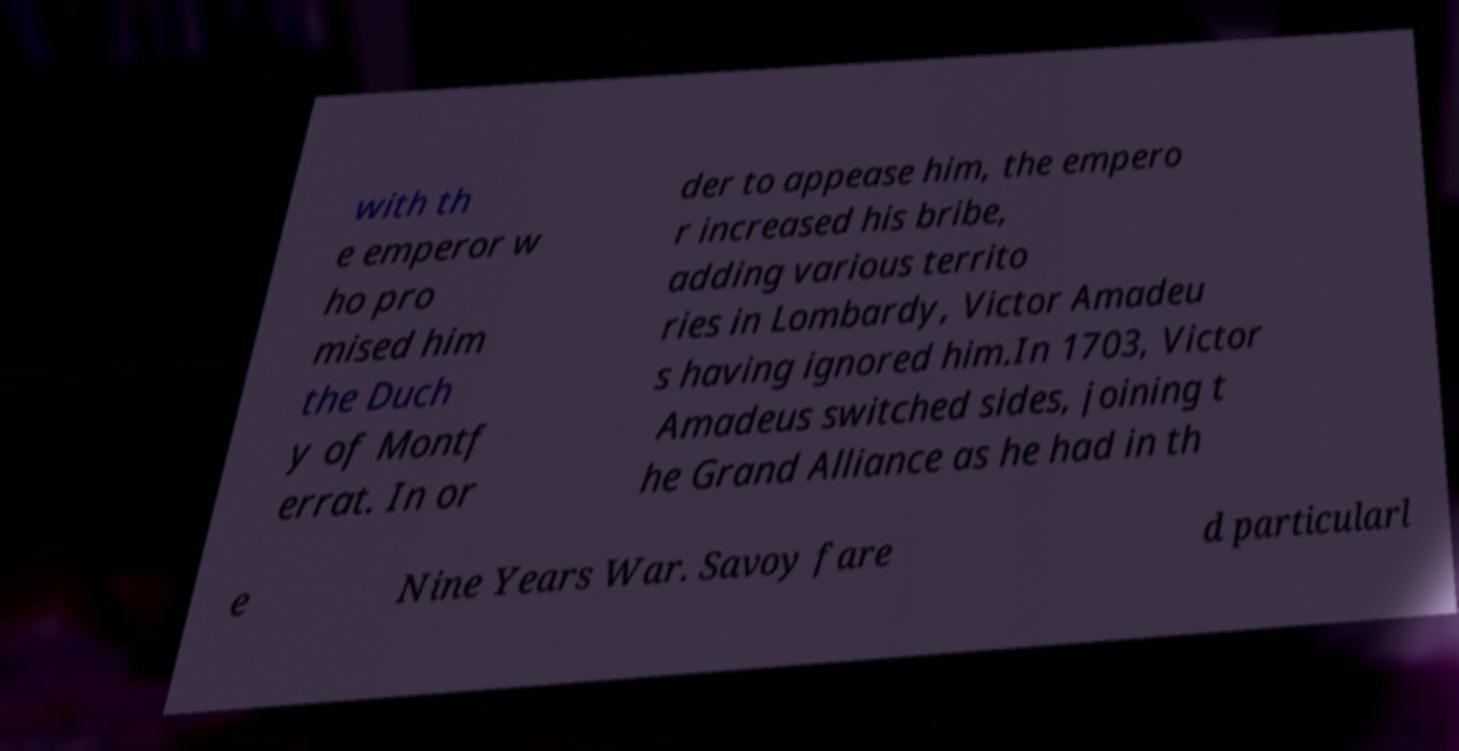Can you accurately transcribe the text from the provided image for me? with th e emperor w ho pro mised him the Duch y of Montf errat. In or der to appease him, the empero r increased his bribe, adding various territo ries in Lombardy, Victor Amadeu s having ignored him.In 1703, Victor Amadeus switched sides, joining t he Grand Alliance as he had in th e Nine Years War. Savoy fare d particularl 